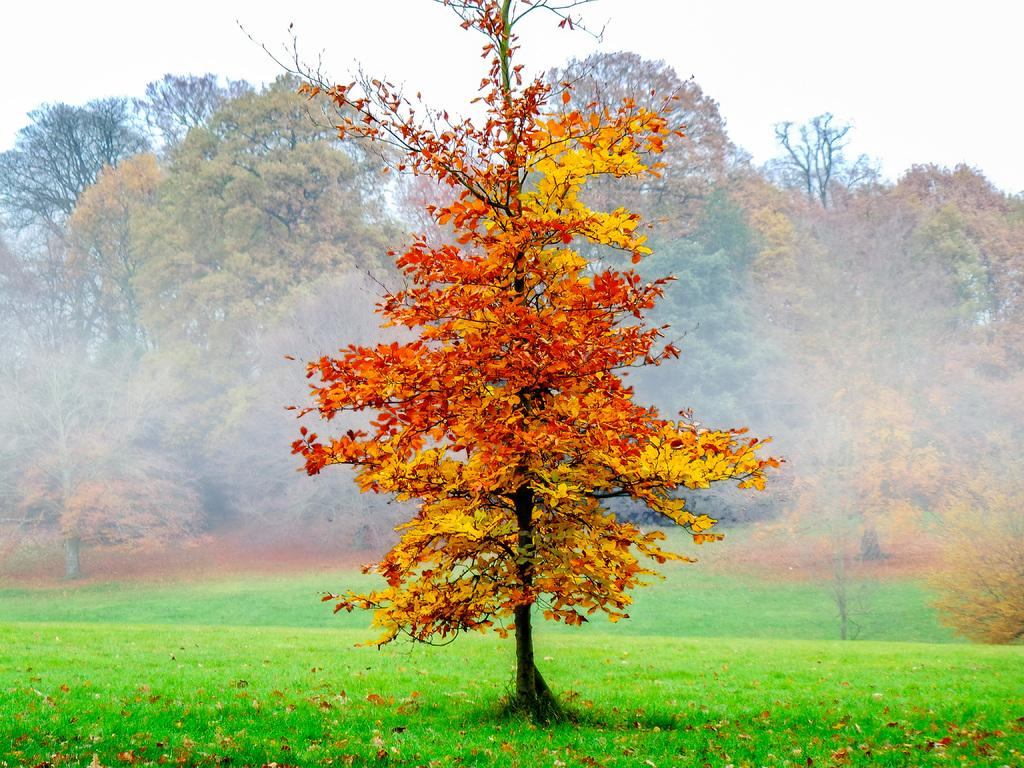What is located in the foreground of the image? There are dry leaves and grass in the foreground of the image. What else can be seen in the foreground of the image? There is a tree in the foreground of the image. What is visible in the middle of the image? There are trees in the middle of the image. What is visible at the top of the image? The sky is visible at the top of the image. Can you tell me how many beggars are visible in the image? There are no beggars present in the image. What type of marble is used to decorate the tree in the image? There is no marble present in the image; it features trees and dry leaves in a natural setting. 